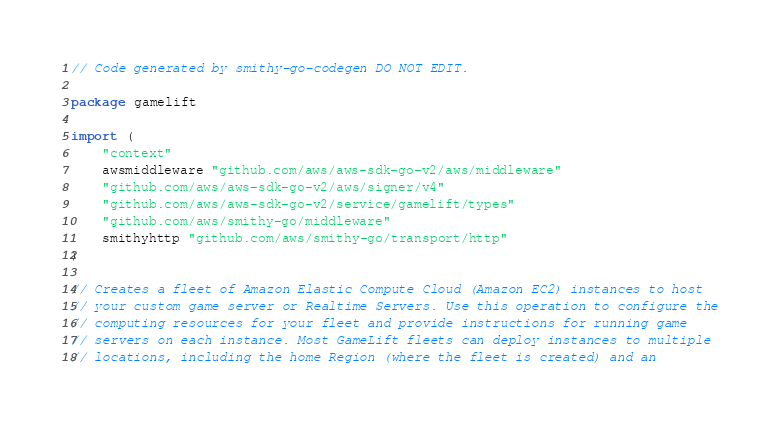Convert code to text. <code><loc_0><loc_0><loc_500><loc_500><_Go_>// Code generated by smithy-go-codegen DO NOT EDIT.

package gamelift

import (
	"context"
	awsmiddleware "github.com/aws/aws-sdk-go-v2/aws/middleware"
	"github.com/aws/aws-sdk-go-v2/aws/signer/v4"
	"github.com/aws/aws-sdk-go-v2/service/gamelift/types"
	"github.com/aws/smithy-go/middleware"
	smithyhttp "github.com/aws/smithy-go/transport/http"
)

// Creates a fleet of Amazon Elastic Compute Cloud (Amazon EC2) instances to host
// your custom game server or Realtime Servers. Use this operation to configure the
// computing resources for your fleet and provide instructions for running game
// servers on each instance. Most GameLift fleets can deploy instances to multiple
// locations, including the home Region (where the fleet is created) and an</code> 